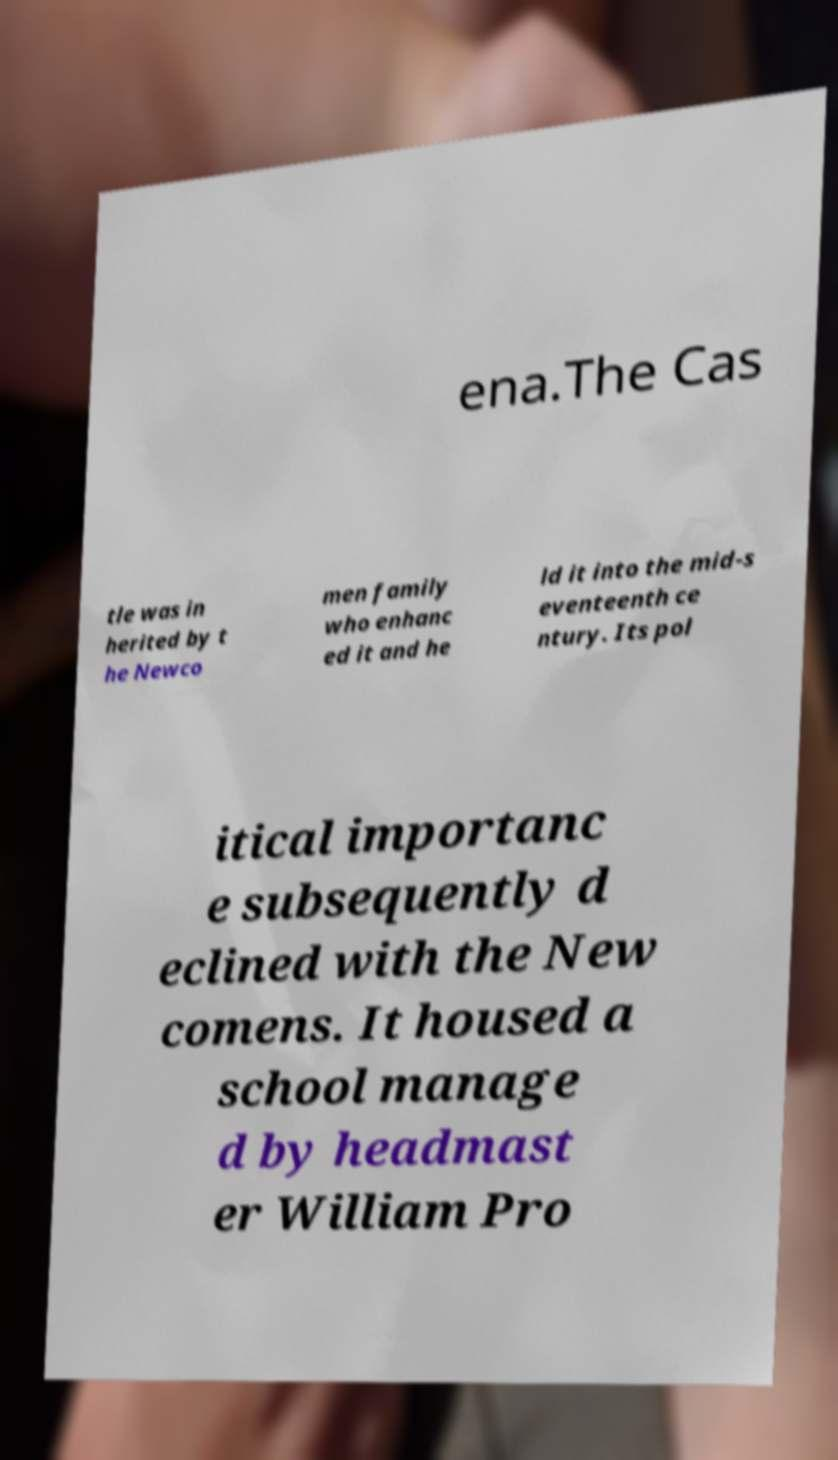There's text embedded in this image that I need extracted. Can you transcribe it verbatim? ena.The Cas tle was in herited by t he Newco men family who enhanc ed it and he ld it into the mid-s eventeenth ce ntury. Its pol itical importanc e subsequently d eclined with the New comens. It housed a school manage d by headmast er William Pro 